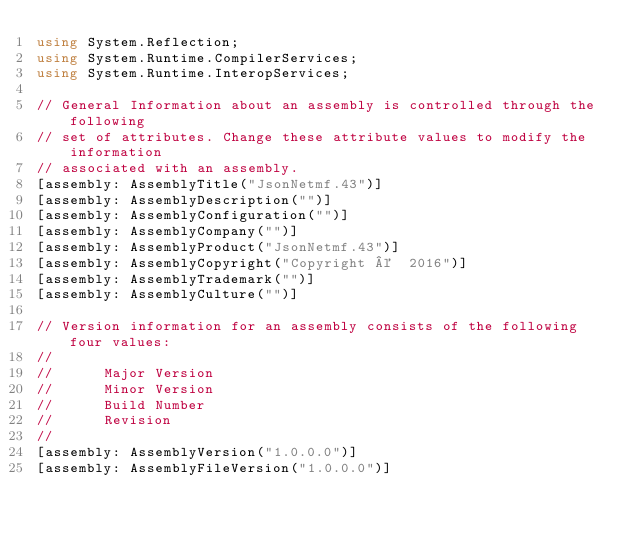<code> <loc_0><loc_0><loc_500><loc_500><_C#_>using System.Reflection;
using System.Runtime.CompilerServices;
using System.Runtime.InteropServices;

// General Information about an assembly is controlled through the following 
// set of attributes. Change these attribute values to modify the information
// associated with an assembly.
[assembly: AssemblyTitle("JsonNetmf.43")]
[assembly: AssemblyDescription("")]
[assembly: AssemblyConfiguration("")]
[assembly: AssemblyCompany("")]
[assembly: AssemblyProduct("JsonNetmf.43")]
[assembly: AssemblyCopyright("Copyright ©  2016")]
[assembly: AssemblyTrademark("")]
[assembly: AssemblyCulture("")]

// Version information for an assembly consists of the following four values:
//
//      Major Version
//      Minor Version 
//      Build Number
//      Revision
//
[assembly: AssemblyVersion("1.0.0.0")]
[assembly: AssemblyFileVersion("1.0.0.0")]
</code> 